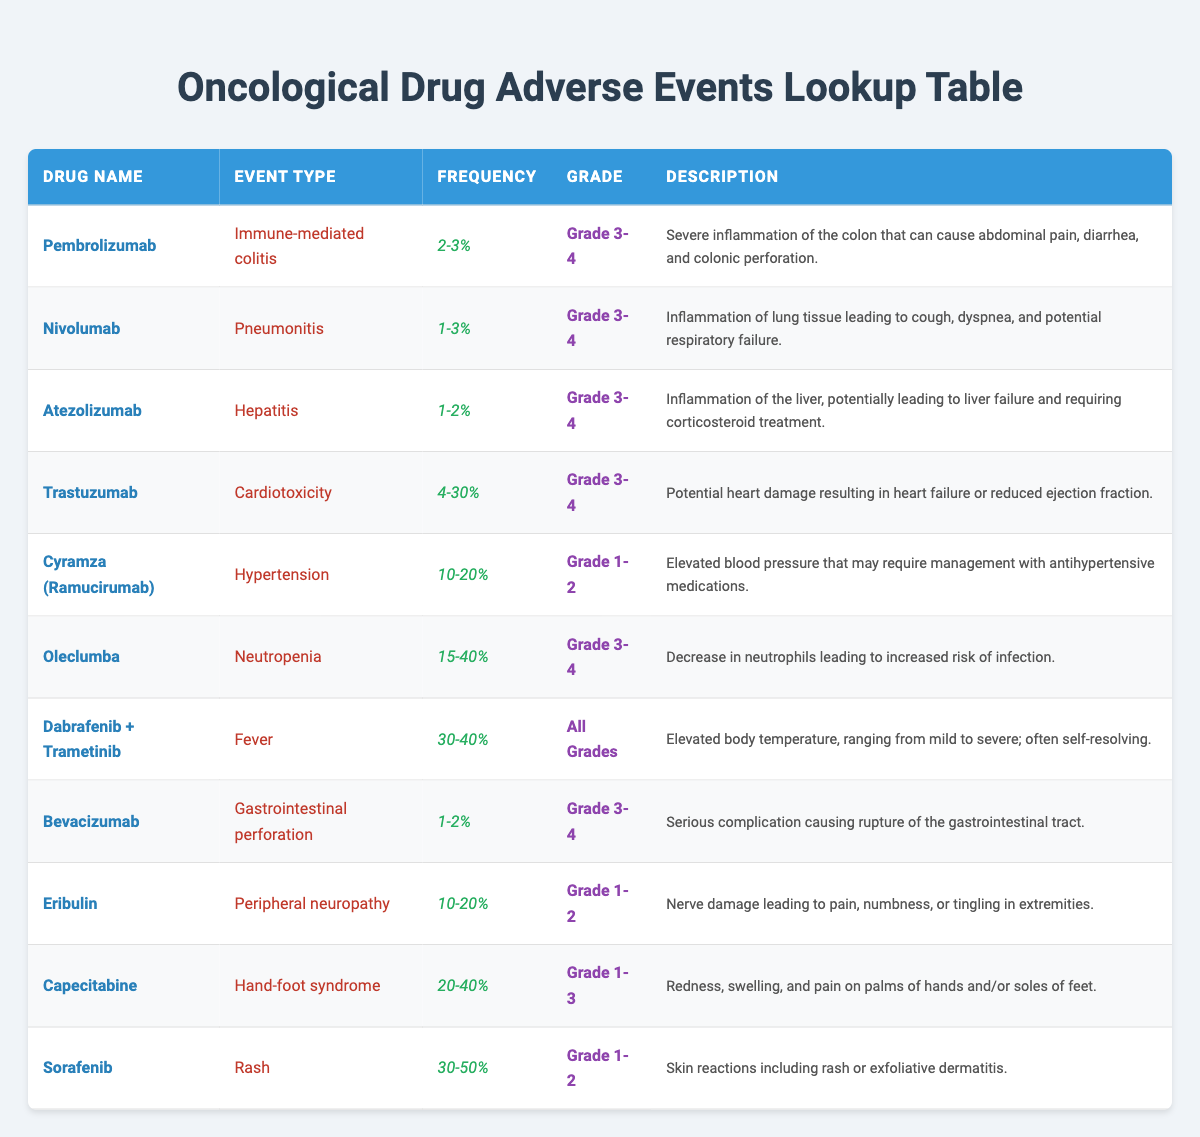What is the frequency range of cardiotoxicity when using Trastuzumab? The frequency range for cardiotoxicity associated with Trastuzumab is listed as 4-30%. This information can be found directly in the table under the "Frequency" column for Trastuzumab.
Answer: 4-30% Which drug has the highest reported frequency of adverse events? By examining the "Frequency" column for all drugs in the table, it can be noted that Sorafenib has a frequency range of 30-50%, which is the highest reported in this dataset.
Answer: 30-50% Is the adverse event of immune-mediated colitis associated with Pembrolizumab? Yes, Pembrolizumab is associated with immune-mediated colitis, as detailed in the "Event Type" column corresponding to Pembrolizumab in the table.
Answer: Yes What percentage of patients might experience neutropenia when taking Oleclumba? The frequency of neutropenia in patients taking Oleclumba is given as 15-40%. This is found under the "Frequency" column for Oleclumba.
Answer: 15-40% How many types of adverse events have a frequency greater than 20%? To find this, we need to check each drug's frequency of adverse events. The drugs that exceed 20% are: Dabrafenib + Trametinib (30-40%), Capecitabine (20-40%), and Sorafenib (30-50%). Counting these yields three types of adverse events with frequencies greater than 20%.
Answer: 3 Which drug is associated with the highest frequency of fever and what is that frequency? The drug that has the highest frequency of fever is Dabrafenib + Trametinib, listed at 30-40%. This is confirmed by looking at the frequency mentioned in the table next to the event type of fever.
Answer: 30-40% What is the frequency of gastrointestinal perforation associated with Bevacizumab? The frequency of gastrointestinal perforation when using Bevacizumab is 1-2%, as indicated in the "Frequency" column next to the relevant event.
Answer: 1-2% Does Capecitabine cause any adverse events graded as Grade 4? No, all adverse events listed for Capecitabine fall within the Grade 1-3 range. This can be seen by checking the "Grade" column next to the event type for Capecitabine in the table.
Answer: No What is the difference in the frequency of rash between Sorafenib and the frequency of hypertension in Cyramza (Ramucirumab)? Sorafenib has a frequency range of 30-50% for rash, while Cyramza (Ramucirumab) has a frequency of 10-20% for hypertension. To find the difference, we take the lower end of Sorafenib (30%) and subtract the upper end of Cyramza (20%), which results in a 10% difference.
Answer: 10% 